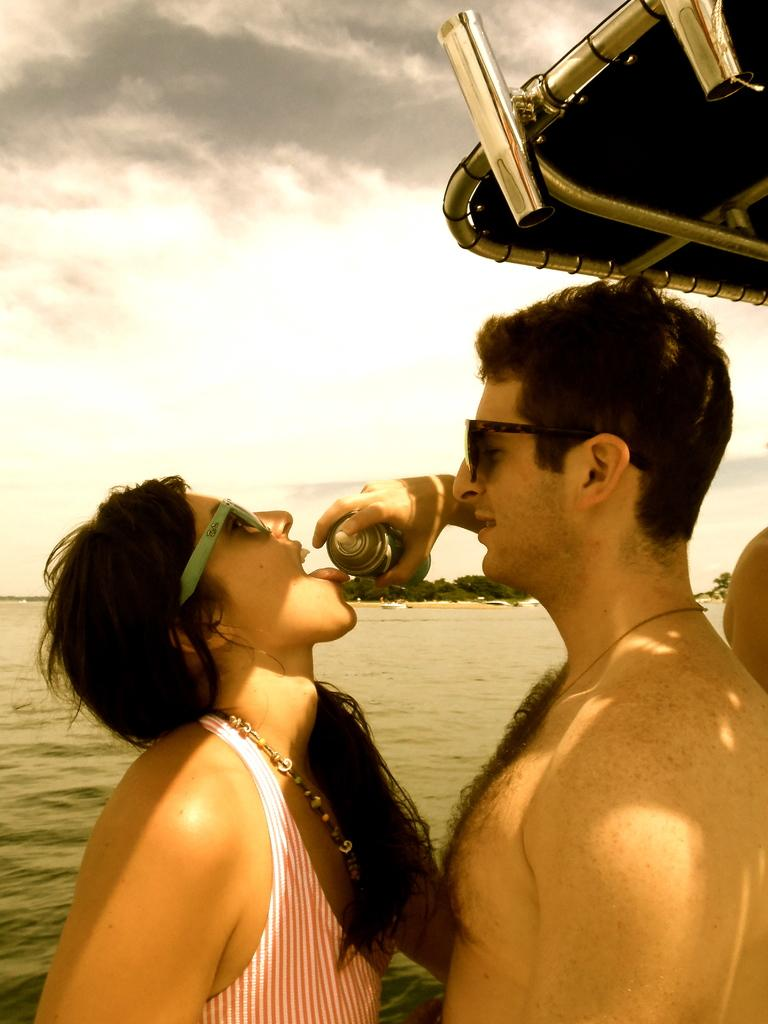How many people are in the image? There are people in the image, but the exact number is not specified. What are two people wearing in the image? Two people are wearing goggles in the image. What is one person holding in the image? One person is holding a tin in the image. What can be seen in the background of the image? Water, trees, clouds, and the sky are visible in the background of the image. What type of pie is being baked on the coal in the image? There is no pie or coal present in the image. What type of ship can be seen sailing in the background of the image? There is no ship visible in the background of the image. 